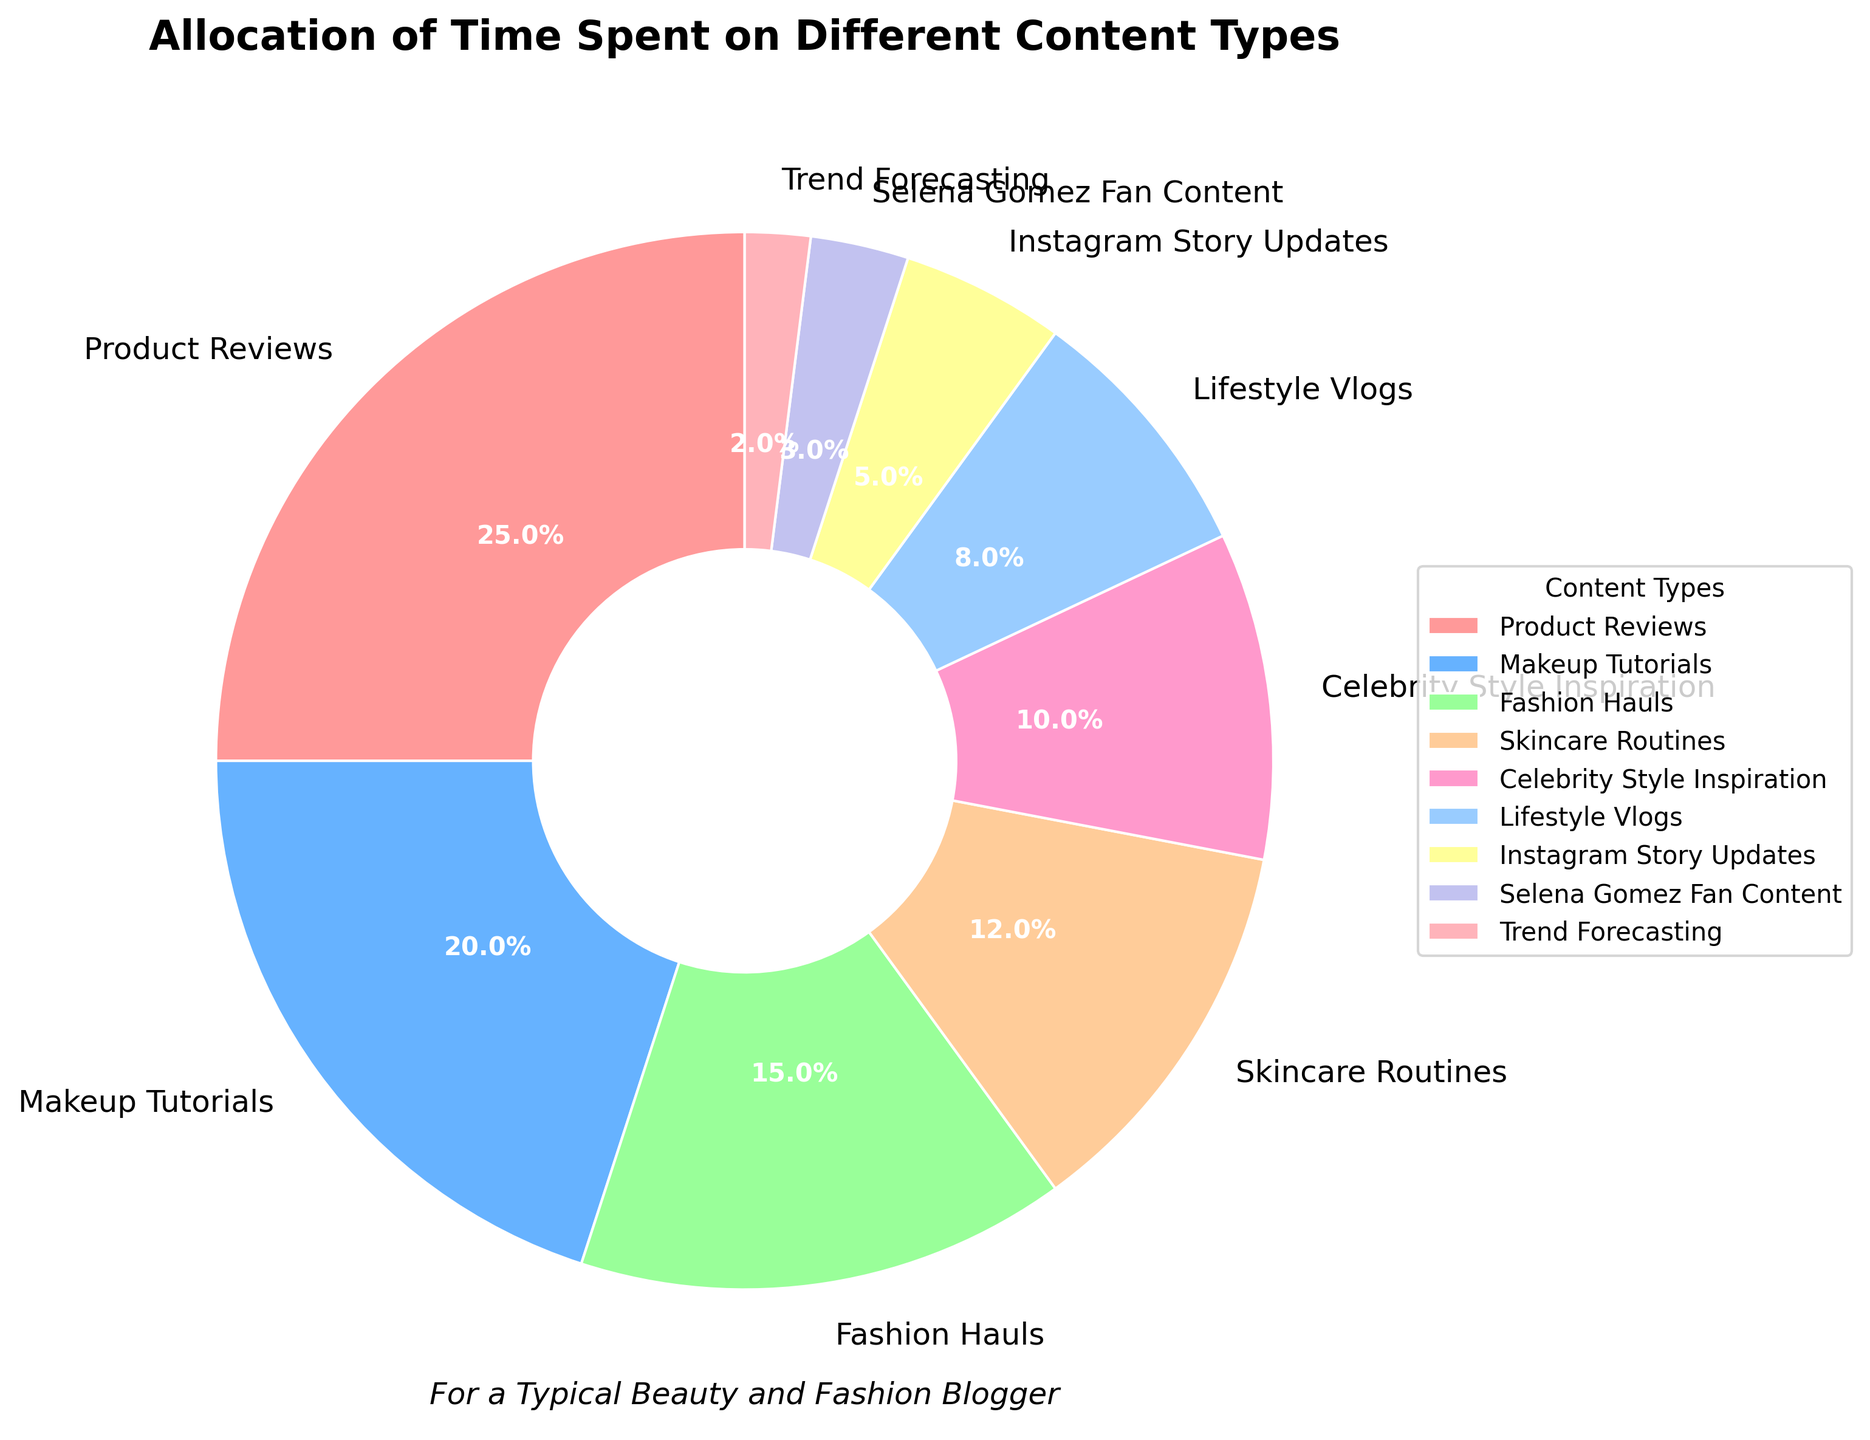Which content type takes up the largest portion of the pie chart? The largest portion in the pie chart is represented by the content type with the highest percentage. "Product Reviews" has the largest percentage at 25%.
Answer: Product Reviews Which content type takes up the smallest portion of the pie chart? The smallest portion in the pie chart is represented by the content type with the smallest percentage. "Trend Forecasting" has the smallest percentage at 2%.
Answer: Trend Forecasting How many percentage points more do Product Reviews have compared to Makeup Tutorials? Product Reviews have 25%, and Makeup Tutorials have 20%. The difference is 25% - 20% = 5%.
Answer: 5% What is the combined percentage of time spent on Skincare Routines, Celebrity Style Inspiration, and Trend Forecasting? Skincare Routines take up 12%, Celebrity Style Inspiration 10%, and Trend Forecasting 2%. Combined, the total is 12% + 10% + 2% = 24%.
Answer: 24% Which two content types have the same color in the chart? Different content types in the pie chart have unique colors, so no two content types share the same color.
Answer: None By how many percentage points does Fashion Hauls exceed Selena Gomez Fan Content? Fashion Hauls have 15%, and Selena Gomez Fan Content has 3%. The difference is 15% - 3% = 12%.
Answer: 12% How does the percentage of time spent on Lifestyle Vlogs compare to Instagram Story Updates? Lifestyle Vlogs have a larger percentage (8%) compared to Instagram Story Updates (5%).
Answer: Larger Is the total percentage of time spent on Makeup Tutorials and Fashion Hauls greater or less than 40%? The total percentage is 20% for Makeup Tutorials and 15% for Fashion Hauls. Together, they add up to 20% + 15% = 35%, which is less than 40%.
Answer: Less What's the difference in the percentage of time spent on the top two content types? The top two content types are Product Reviews (25%) and Makeup Tutorials (20%). The difference is 25% - 20% = 5%.
Answer: 5% What percentage of the pie chart does Selena Gomez Fan Content occupy? Selena Gomez Fan Content occupies 3% of the pie chart.
Answer: 3% 